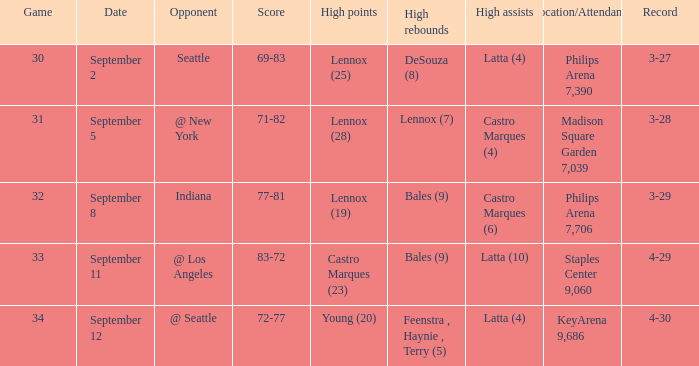What were the high recoveries on september 11? Bales (9). 